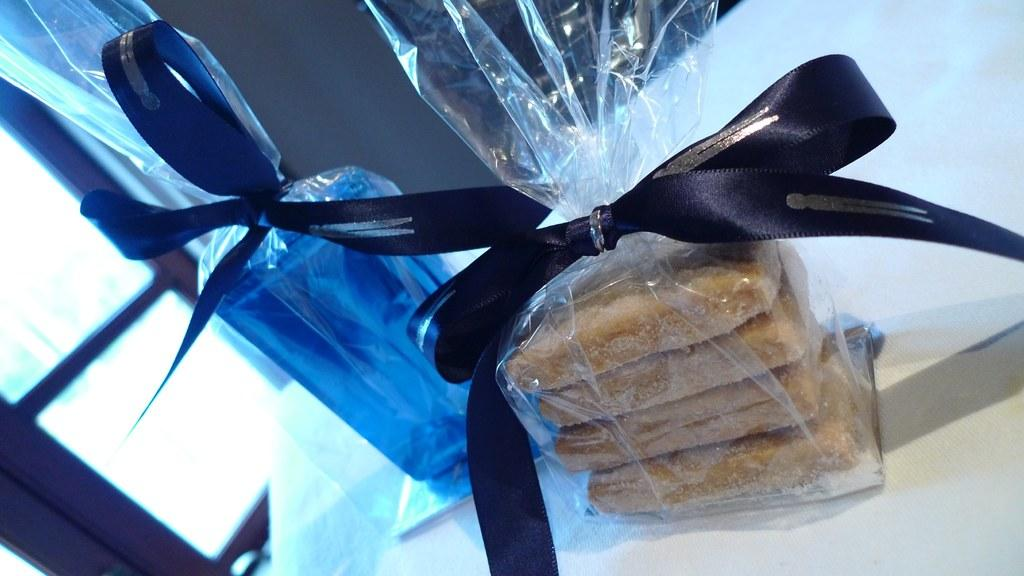What type of items can be seen in the image? There are food items and a glass object in the image. How are the food items and glass object packaged? The food items and glass object are packed with plastic covers. What additional decoration is present on the food items and glass object? The food items and glass object have ribbons on them. Where are the food items and glass object placed? They are placed on a platform. What can be seen in the background of the image? There is a door visible in the background of the image. What type of coach is visible in the image? There is no coach present in the image. What type of wax can be seen dripping from the glass object in the image? There is no wax present in the image, and the glass object is not shown to be dripping anything. 